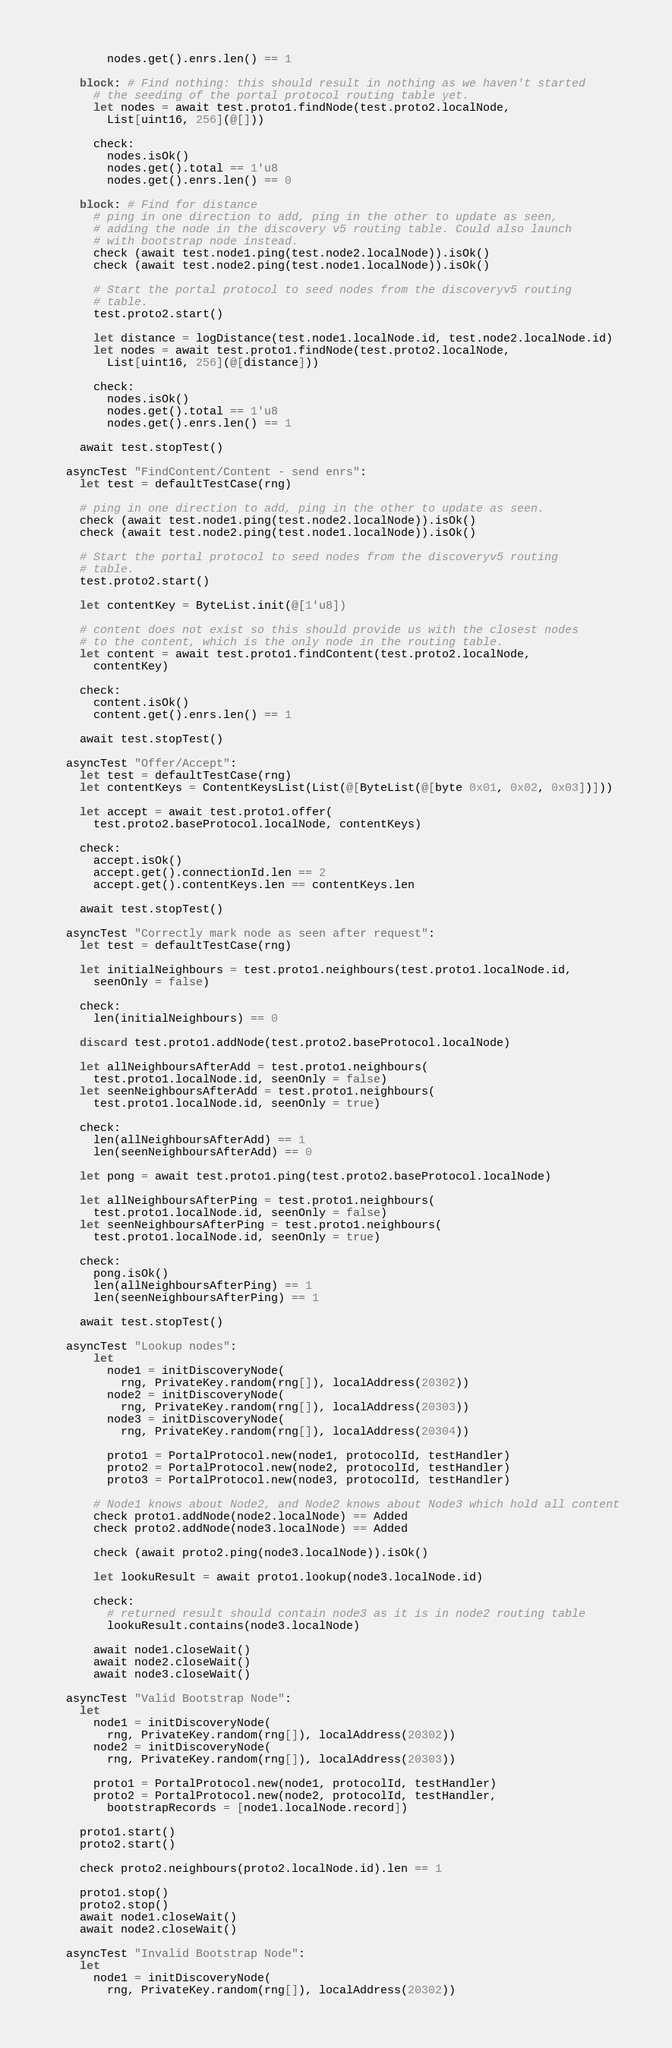<code> <loc_0><loc_0><loc_500><loc_500><_Nim_>        nodes.get().enrs.len() == 1

    block: # Find nothing: this should result in nothing as we haven't started
      # the seeding of the portal protocol routing table yet.
      let nodes = await test.proto1.findNode(test.proto2.localNode,
        List[uint16, 256](@[]))

      check:
        nodes.isOk()
        nodes.get().total == 1'u8
        nodes.get().enrs.len() == 0

    block: # Find for distance
      # ping in one direction to add, ping in the other to update as seen,
      # adding the node in the discovery v5 routing table. Could also launch
      # with bootstrap node instead.
      check (await test.node1.ping(test.node2.localNode)).isOk()
      check (await test.node2.ping(test.node1.localNode)).isOk()

      # Start the portal protocol to seed nodes from the discoveryv5 routing
      # table.
      test.proto2.start()

      let distance = logDistance(test.node1.localNode.id, test.node2.localNode.id)
      let nodes = await test.proto1.findNode(test.proto2.localNode,
        List[uint16, 256](@[distance]))

      check:
        nodes.isOk()
        nodes.get().total == 1'u8
        nodes.get().enrs.len() == 1
    
    await test.stopTest()

  asyncTest "FindContent/Content - send enrs":
    let test = defaultTestCase(rng)

    # ping in one direction to add, ping in the other to update as seen.
    check (await test.node1.ping(test.node2.localNode)).isOk()
    check (await test.node2.ping(test.node1.localNode)).isOk()

    # Start the portal protocol to seed nodes from the discoveryv5 routing
    # table.
    test.proto2.start()

    let contentKey = ByteList.init(@[1'u8])

    # content does not exist so this should provide us with the closest nodes
    # to the content, which is the only node in the routing table.
    let content = await test.proto1.findContent(test.proto2.localNode,
      contentKey)

    check:
      content.isOk()
      content.get().enrs.len() == 1

    await test.stopTest()

  asyncTest "Offer/Accept":
    let test = defaultTestCase(rng)
    let contentKeys = ContentKeysList(List(@[ByteList(@[byte 0x01, 0x02, 0x03])]))

    let accept = await test.proto1.offer(
      test.proto2.baseProtocol.localNode, contentKeys)

    check:
      accept.isOk()
      accept.get().connectionId.len == 2
      accept.get().contentKeys.len == contentKeys.len

    await test.stopTest()

  asyncTest "Correctly mark node as seen after request":
    let test = defaultTestCase(rng)

    let initialNeighbours = test.proto1.neighbours(test.proto1.localNode.id,
      seenOnly = false)

    check:
      len(initialNeighbours) == 0

    discard test.proto1.addNode(test.proto2.baseProtocol.localNode)

    let allNeighboursAfterAdd = test.proto1.neighbours(
      test.proto1.localNode.id, seenOnly = false)
    let seenNeighboursAfterAdd = test.proto1.neighbours(
      test.proto1.localNode.id, seenOnly = true)

    check:
      len(allNeighboursAfterAdd) == 1
      len(seenNeighboursAfterAdd) == 0

    let pong = await test.proto1.ping(test.proto2.baseProtocol.localNode)

    let allNeighboursAfterPing = test.proto1.neighbours(
      test.proto1.localNode.id, seenOnly = false)
    let seenNeighboursAfterPing = test.proto1.neighbours(
      test.proto1.localNode.id, seenOnly = true)

    check:
      pong.isOk()
      len(allNeighboursAfterPing) == 1
      len(seenNeighboursAfterPing) == 1

    await test.stopTest()

  asyncTest "Lookup nodes":
      let
        node1 = initDiscoveryNode(
          rng, PrivateKey.random(rng[]), localAddress(20302))
        node2 = initDiscoveryNode(
          rng, PrivateKey.random(rng[]), localAddress(20303))
        node3 = initDiscoveryNode(
          rng, PrivateKey.random(rng[]), localAddress(20304))

        proto1 = PortalProtocol.new(node1, protocolId, testHandler)
        proto2 = PortalProtocol.new(node2, protocolId, testHandler)
        proto3 = PortalProtocol.new(node3, protocolId, testHandler)

      # Node1 knows about Node2, and Node2 knows about Node3 which hold all content
      check proto1.addNode(node2.localNode) == Added
      check proto2.addNode(node3.localNode) == Added

      check (await proto2.ping(node3.localNode)).isOk()

      let lookuResult = await proto1.lookup(node3.localNode.id)

      check:
        # returned result should contain node3 as it is in node2 routing table
        lookuResult.contains(node3.localNode)

      await node1.closeWait()
      await node2.closeWait()
      await node3.closeWait()

  asyncTest "Valid Bootstrap Node":
    let
      node1 = initDiscoveryNode(
        rng, PrivateKey.random(rng[]), localAddress(20302))
      node2 = initDiscoveryNode(
        rng, PrivateKey.random(rng[]), localAddress(20303))

      proto1 = PortalProtocol.new(node1, protocolId, testHandler)
      proto2 = PortalProtocol.new(node2, protocolId, testHandler,
        bootstrapRecords = [node1.localNode.record])

    proto1.start()
    proto2.start()

    check proto2.neighbours(proto2.localNode.id).len == 1

    proto1.stop()
    proto2.stop()
    await node1.closeWait()
    await node2.closeWait()

  asyncTest "Invalid Bootstrap Node":
    let
      node1 = initDiscoveryNode(
        rng, PrivateKey.random(rng[]), localAddress(20302))</code> 